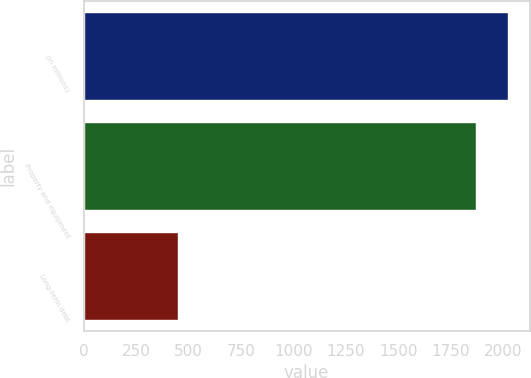Convert chart to OTSL. <chart><loc_0><loc_0><loc_500><loc_500><bar_chart><fcel>(in millions)<fcel>Property and equipment<fcel>Long-term debt<nl><fcel>2024.5<fcel>1868<fcel>450<nl></chart> 